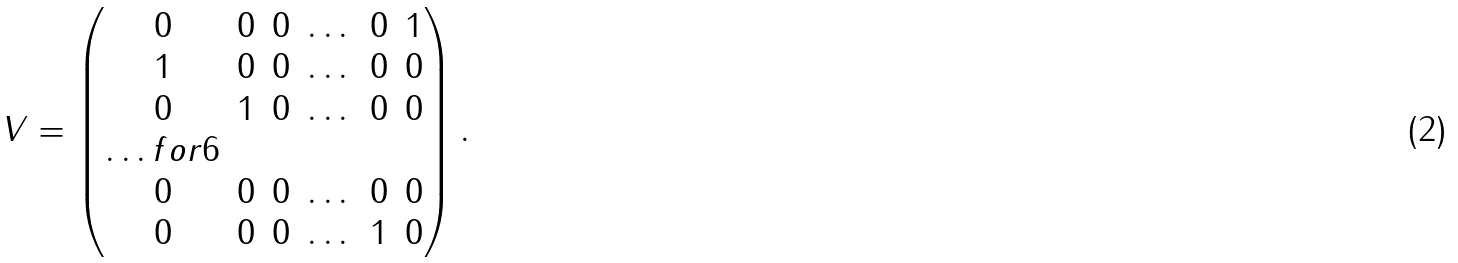Convert formula to latex. <formula><loc_0><loc_0><loc_500><loc_500>V = \begin{pmatrix} 0 & 0 & 0 & \dots & 0 & 1 \\ 1 & 0 & 0 & \dots & 0 & 0 \\ 0 & 1 & 0 & \dots & 0 & 0 \\ \hdots f o r { 6 } \\ 0 & 0 & 0 & \dots & 0 & 0 \\ 0 & 0 & 0 & \dots & 1 & 0 \\ \end{pmatrix} .</formula> 